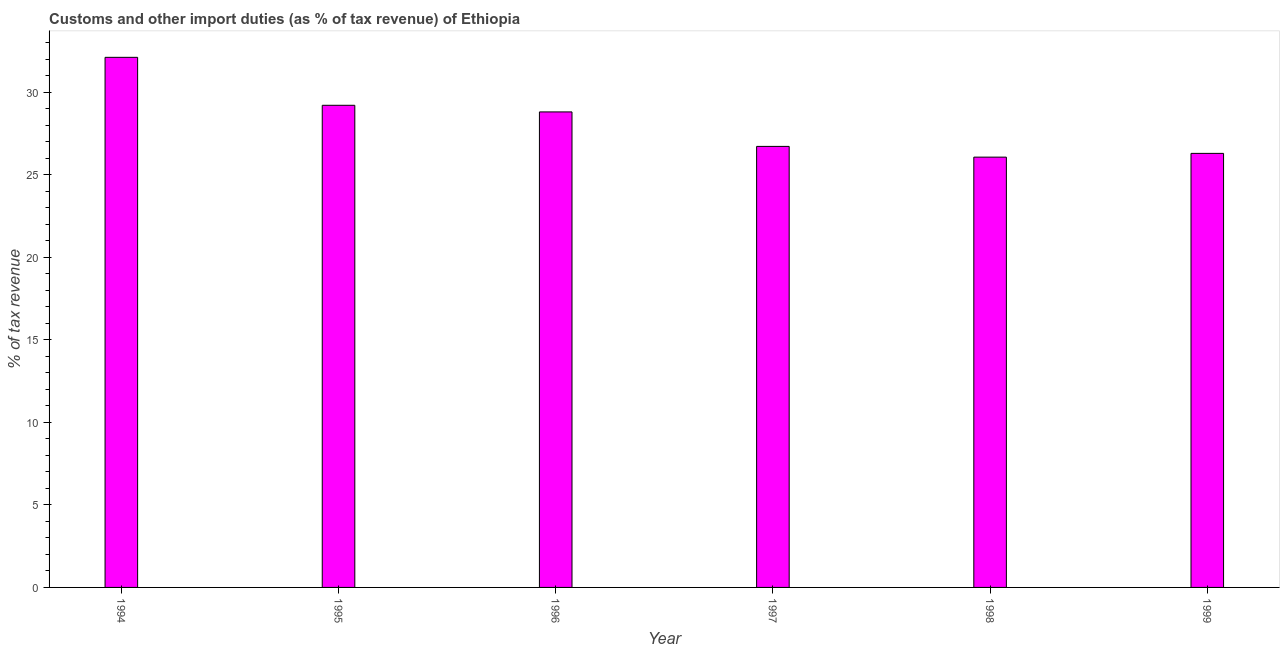Does the graph contain any zero values?
Your answer should be very brief. No. What is the title of the graph?
Your answer should be compact. Customs and other import duties (as % of tax revenue) of Ethiopia. What is the label or title of the Y-axis?
Your answer should be compact. % of tax revenue. What is the customs and other import duties in 1999?
Give a very brief answer. 26.29. Across all years, what is the maximum customs and other import duties?
Your answer should be compact. 32.11. Across all years, what is the minimum customs and other import duties?
Your response must be concise. 26.07. In which year was the customs and other import duties maximum?
Provide a succinct answer. 1994. What is the sum of the customs and other import duties?
Offer a terse response. 169.2. What is the difference between the customs and other import duties in 1998 and 1999?
Your answer should be very brief. -0.23. What is the average customs and other import duties per year?
Offer a very short reply. 28.2. What is the median customs and other import duties?
Your response must be concise. 27.76. Do a majority of the years between 1998 and 1994 (inclusive) have customs and other import duties greater than 32 %?
Make the answer very short. Yes. What is the ratio of the customs and other import duties in 1995 to that in 1997?
Provide a succinct answer. 1.09. What is the difference between the highest and the second highest customs and other import duties?
Provide a short and direct response. 2.9. Is the sum of the customs and other import duties in 1994 and 1997 greater than the maximum customs and other import duties across all years?
Your answer should be compact. Yes. What is the difference between the highest and the lowest customs and other import duties?
Make the answer very short. 6.05. In how many years, is the customs and other import duties greater than the average customs and other import duties taken over all years?
Ensure brevity in your answer.  3. What is the % of tax revenue in 1994?
Provide a short and direct response. 32.11. What is the % of tax revenue of 1995?
Give a very brief answer. 29.21. What is the % of tax revenue in 1996?
Give a very brief answer. 28.81. What is the % of tax revenue of 1997?
Provide a short and direct response. 26.72. What is the % of tax revenue in 1998?
Keep it short and to the point. 26.07. What is the % of tax revenue in 1999?
Make the answer very short. 26.29. What is the difference between the % of tax revenue in 1994 and 1995?
Make the answer very short. 2.91. What is the difference between the % of tax revenue in 1994 and 1996?
Provide a succinct answer. 3.31. What is the difference between the % of tax revenue in 1994 and 1997?
Offer a terse response. 5.4. What is the difference between the % of tax revenue in 1994 and 1998?
Make the answer very short. 6.05. What is the difference between the % of tax revenue in 1994 and 1999?
Your answer should be very brief. 5.82. What is the difference between the % of tax revenue in 1995 and 1996?
Offer a terse response. 0.4. What is the difference between the % of tax revenue in 1995 and 1997?
Your answer should be compact. 2.49. What is the difference between the % of tax revenue in 1995 and 1998?
Your answer should be compact. 3.14. What is the difference between the % of tax revenue in 1995 and 1999?
Ensure brevity in your answer.  2.91. What is the difference between the % of tax revenue in 1996 and 1997?
Give a very brief answer. 2.09. What is the difference between the % of tax revenue in 1996 and 1998?
Give a very brief answer. 2.74. What is the difference between the % of tax revenue in 1996 and 1999?
Your answer should be compact. 2.51. What is the difference between the % of tax revenue in 1997 and 1998?
Your response must be concise. 0.65. What is the difference between the % of tax revenue in 1997 and 1999?
Give a very brief answer. 0.42. What is the difference between the % of tax revenue in 1998 and 1999?
Ensure brevity in your answer.  -0.23. What is the ratio of the % of tax revenue in 1994 to that in 1995?
Ensure brevity in your answer.  1.1. What is the ratio of the % of tax revenue in 1994 to that in 1996?
Make the answer very short. 1.11. What is the ratio of the % of tax revenue in 1994 to that in 1997?
Your response must be concise. 1.2. What is the ratio of the % of tax revenue in 1994 to that in 1998?
Your answer should be compact. 1.23. What is the ratio of the % of tax revenue in 1994 to that in 1999?
Make the answer very short. 1.22. What is the ratio of the % of tax revenue in 1995 to that in 1996?
Keep it short and to the point. 1.01. What is the ratio of the % of tax revenue in 1995 to that in 1997?
Ensure brevity in your answer.  1.09. What is the ratio of the % of tax revenue in 1995 to that in 1998?
Offer a very short reply. 1.12. What is the ratio of the % of tax revenue in 1995 to that in 1999?
Your answer should be compact. 1.11. What is the ratio of the % of tax revenue in 1996 to that in 1997?
Make the answer very short. 1.08. What is the ratio of the % of tax revenue in 1996 to that in 1998?
Provide a short and direct response. 1.1. What is the ratio of the % of tax revenue in 1996 to that in 1999?
Ensure brevity in your answer.  1.1. What is the ratio of the % of tax revenue in 1997 to that in 1999?
Provide a short and direct response. 1.02. 